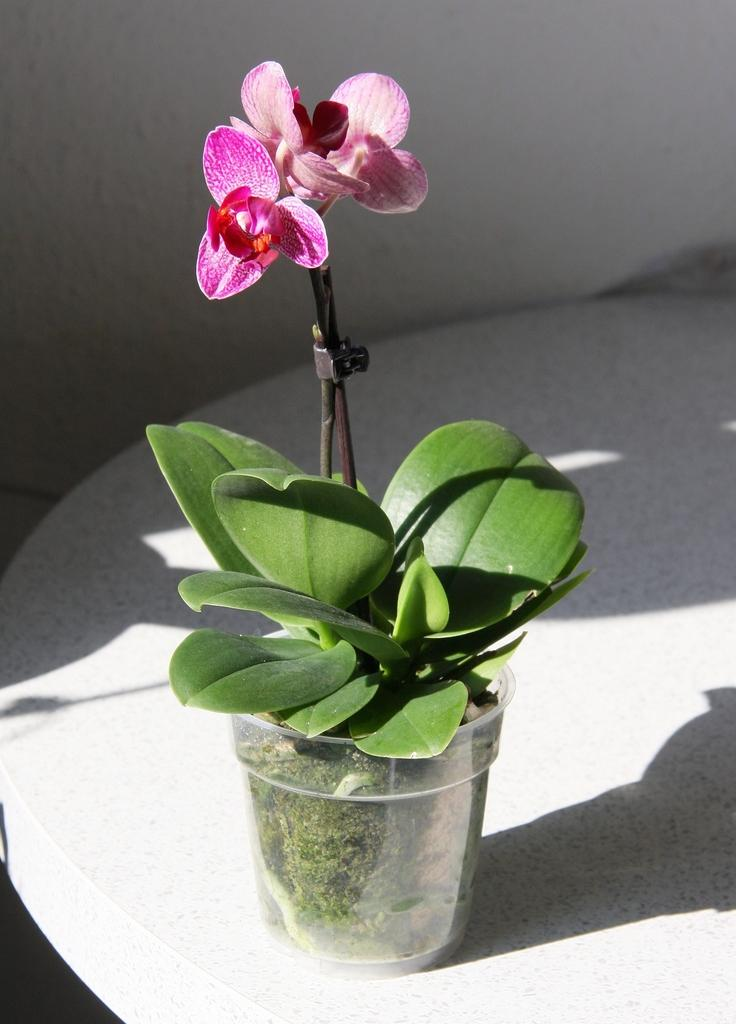What is located in the foreground of the image? There is a flower pot in the foreground of the image. What is the flower pot placed on? The flower pot is on a white surface. What can be seen in the background of the image? There is a white wall in the background of the image. How many horses are visible in the image? There are no horses present in the image. What type of food is being prepared on the white surface? There is no food preparation visible in the image; it only features a flower pot on a white surface. 